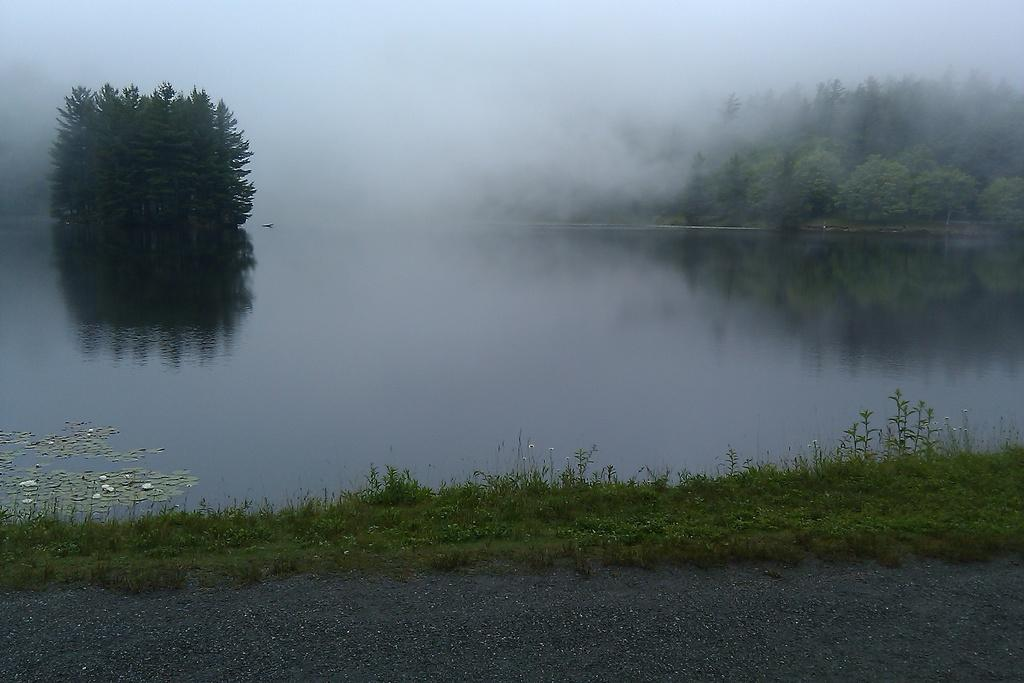Where was the image taken? The image was clicked outside. What can be seen in the water in the image? The facts do not specify what is in the water, only that water is visible. What type of vegetation is present in the image? There are trees in the image. What is the weather like in the image? The presence of snow in the image suggests a cold or wintery weather condition. What type of plastic material can be seen floating in the water in the image? There is no plastic material visible in the water in the image. What sound can be heard coming from the railway in the image? There is no railway present in the image, so no sound can be heard from a railway. 